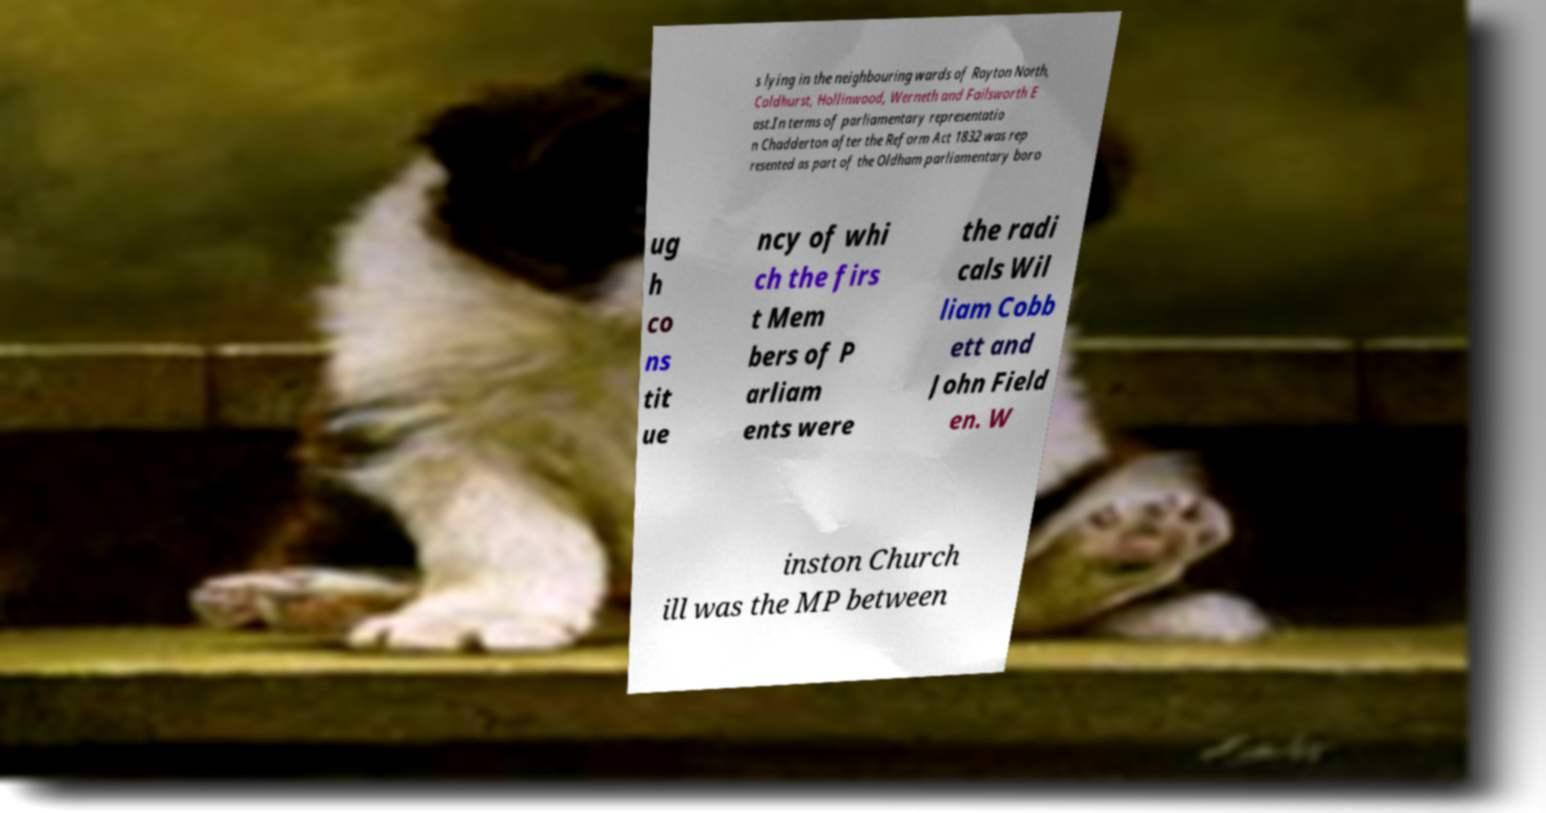For documentation purposes, I need the text within this image transcribed. Could you provide that? s lying in the neighbouring wards of Royton North, Coldhurst, Hollinwood, Werneth and Failsworth E ast.In terms of parliamentary representatio n Chadderton after the Reform Act 1832 was rep resented as part of the Oldham parliamentary boro ug h co ns tit ue ncy of whi ch the firs t Mem bers of P arliam ents were the radi cals Wil liam Cobb ett and John Field en. W inston Church ill was the MP between 